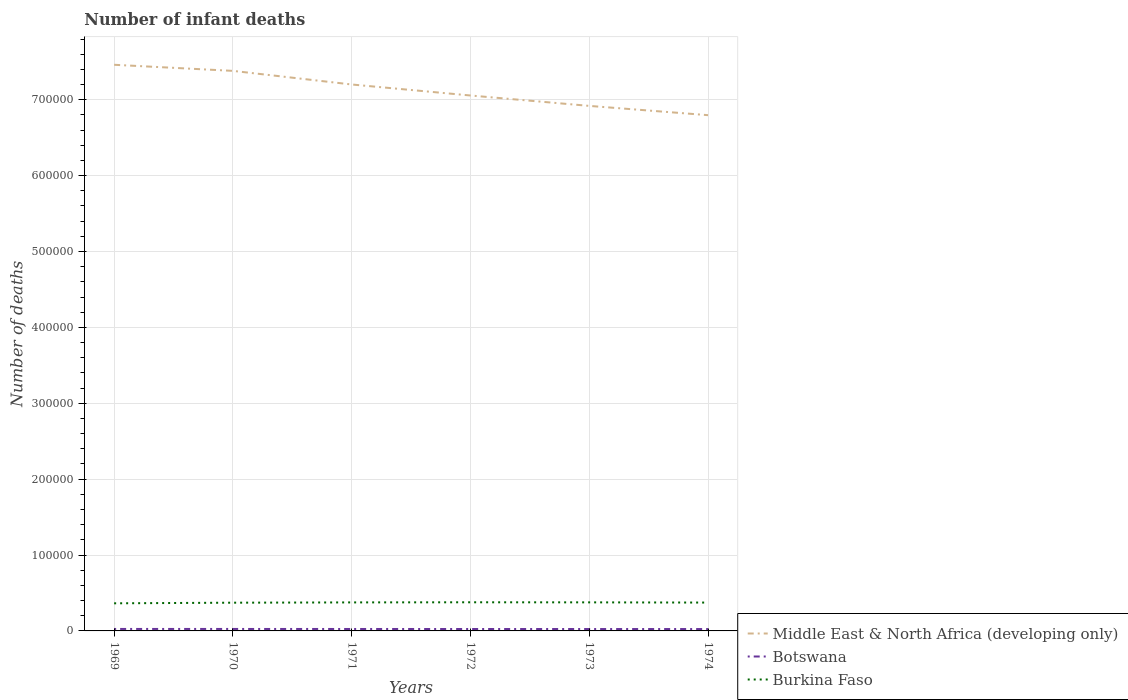Is the number of lines equal to the number of legend labels?
Provide a short and direct response. Yes. Across all years, what is the maximum number of infant deaths in Botswana?
Provide a succinct answer. 2476. In which year was the number of infant deaths in Burkina Faso maximum?
Offer a very short reply. 1969. What is the total number of infant deaths in Botswana in the graph?
Your response must be concise. 127. What is the difference between the highest and the second highest number of infant deaths in Middle East & North Africa (developing only)?
Make the answer very short. 6.64e+04. What is the difference between the highest and the lowest number of infant deaths in Botswana?
Make the answer very short. 3. How many lines are there?
Make the answer very short. 3. How many years are there in the graph?
Offer a very short reply. 6. How are the legend labels stacked?
Your response must be concise. Vertical. What is the title of the graph?
Your answer should be compact. Number of infant deaths. What is the label or title of the Y-axis?
Provide a short and direct response. Number of deaths. What is the Number of deaths of Middle East & North Africa (developing only) in 1969?
Keep it short and to the point. 7.46e+05. What is the Number of deaths of Botswana in 1969?
Give a very brief answer. 2603. What is the Number of deaths in Burkina Faso in 1969?
Provide a short and direct response. 3.64e+04. What is the Number of deaths in Middle East & North Africa (developing only) in 1970?
Ensure brevity in your answer.  7.38e+05. What is the Number of deaths of Botswana in 1970?
Your response must be concise. 2587. What is the Number of deaths of Burkina Faso in 1970?
Your answer should be compact. 3.72e+04. What is the Number of deaths in Middle East & North Africa (developing only) in 1971?
Your response must be concise. 7.20e+05. What is the Number of deaths in Botswana in 1971?
Provide a succinct answer. 2557. What is the Number of deaths in Burkina Faso in 1971?
Offer a very short reply. 3.76e+04. What is the Number of deaths of Middle East & North Africa (developing only) in 1972?
Make the answer very short. 7.06e+05. What is the Number of deaths of Botswana in 1972?
Ensure brevity in your answer.  2529. What is the Number of deaths of Burkina Faso in 1972?
Your response must be concise. 3.77e+04. What is the Number of deaths of Middle East & North Africa (developing only) in 1973?
Offer a terse response. 6.92e+05. What is the Number of deaths in Botswana in 1973?
Provide a succinct answer. 2500. What is the Number of deaths in Burkina Faso in 1973?
Offer a very short reply. 3.76e+04. What is the Number of deaths in Middle East & North Africa (developing only) in 1974?
Keep it short and to the point. 6.80e+05. What is the Number of deaths in Botswana in 1974?
Give a very brief answer. 2476. What is the Number of deaths in Burkina Faso in 1974?
Ensure brevity in your answer.  3.74e+04. Across all years, what is the maximum Number of deaths in Middle East & North Africa (developing only)?
Your response must be concise. 7.46e+05. Across all years, what is the maximum Number of deaths of Botswana?
Offer a very short reply. 2603. Across all years, what is the maximum Number of deaths of Burkina Faso?
Give a very brief answer. 3.77e+04. Across all years, what is the minimum Number of deaths of Middle East & North Africa (developing only)?
Your answer should be very brief. 6.80e+05. Across all years, what is the minimum Number of deaths of Botswana?
Provide a succinct answer. 2476. Across all years, what is the minimum Number of deaths of Burkina Faso?
Make the answer very short. 3.64e+04. What is the total Number of deaths of Middle East & North Africa (developing only) in the graph?
Offer a terse response. 4.28e+06. What is the total Number of deaths of Botswana in the graph?
Your response must be concise. 1.53e+04. What is the total Number of deaths in Burkina Faso in the graph?
Make the answer very short. 2.24e+05. What is the difference between the Number of deaths in Middle East & North Africa (developing only) in 1969 and that in 1970?
Offer a very short reply. 8013. What is the difference between the Number of deaths in Burkina Faso in 1969 and that in 1970?
Your answer should be compact. -810. What is the difference between the Number of deaths in Middle East & North Africa (developing only) in 1969 and that in 1971?
Provide a short and direct response. 2.60e+04. What is the difference between the Number of deaths of Burkina Faso in 1969 and that in 1971?
Keep it short and to the point. -1194. What is the difference between the Number of deaths in Middle East & North Africa (developing only) in 1969 and that in 1972?
Provide a short and direct response. 4.05e+04. What is the difference between the Number of deaths of Burkina Faso in 1969 and that in 1972?
Offer a terse response. -1365. What is the difference between the Number of deaths in Middle East & North Africa (developing only) in 1969 and that in 1973?
Your answer should be compact. 5.42e+04. What is the difference between the Number of deaths of Botswana in 1969 and that in 1973?
Provide a succinct answer. 103. What is the difference between the Number of deaths of Burkina Faso in 1969 and that in 1973?
Offer a terse response. -1258. What is the difference between the Number of deaths of Middle East & North Africa (developing only) in 1969 and that in 1974?
Ensure brevity in your answer.  6.64e+04. What is the difference between the Number of deaths of Botswana in 1969 and that in 1974?
Your answer should be compact. 127. What is the difference between the Number of deaths of Burkina Faso in 1969 and that in 1974?
Your response must be concise. -977. What is the difference between the Number of deaths of Middle East & North Africa (developing only) in 1970 and that in 1971?
Your answer should be compact. 1.79e+04. What is the difference between the Number of deaths in Botswana in 1970 and that in 1971?
Provide a succinct answer. 30. What is the difference between the Number of deaths of Burkina Faso in 1970 and that in 1971?
Give a very brief answer. -384. What is the difference between the Number of deaths in Middle East & North Africa (developing only) in 1970 and that in 1972?
Make the answer very short. 3.24e+04. What is the difference between the Number of deaths of Botswana in 1970 and that in 1972?
Your answer should be compact. 58. What is the difference between the Number of deaths in Burkina Faso in 1970 and that in 1972?
Keep it short and to the point. -555. What is the difference between the Number of deaths of Middle East & North Africa (developing only) in 1970 and that in 1973?
Keep it short and to the point. 4.62e+04. What is the difference between the Number of deaths of Botswana in 1970 and that in 1973?
Your response must be concise. 87. What is the difference between the Number of deaths of Burkina Faso in 1970 and that in 1973?
Offer a very short reply. -448. What is the difference between the Number of deaths in Middle East & North Africa (developing only) in 1970 and that in 1974?
Give a very brief answer. 5.84e+04. What is the difference between the Number of deaths in Botswana in 1970 and that in 1974?
Provide a succinct answer. 111. What is the difference between the Number of deaths of Burkina Faso in 1970 and that in 1974?
Ensure brevity in your answer.  -167. What is the difference between the Number of deaths of Middle East & North Africa (developing only) in 1971 and that in 1972?
Keep it short and to the point. 1.45e+04. What is the difference between the Number of deaths in Burkina Faso in 1971 and that in 1972?
Your response must be concise. -171. What is the difference between the Number of deaths in Middle East & North Africa (developing only) in 1971 and that in 1973?
Provide a short and direct response. 2.82e+04. What is the difference between the Number of deaths of Botswana in 1971 and that in 1973?
Ensure brevity in your answer.  57. What is the difference between the Number of deaths in Burkina Faso in 1971 and that in 1973?
Provide a succinct answer. -64. What is the difference between the Number of deaths in Middle East & North Africa (developing only) in 1971 and that in 1974?
Provide a short and direct response. 4.04e+04. What is the difference between the Number of deaths in Burkina Faso in 1971 and that in 1974?
Give a very brief answer. 217. What is the difference between the Number of deaths in Middle East & North Africa (developing only) in 1972 and that in 1973?
Provide a succinct answer. 1.37e+04. What is the difference between the Number of deaths of Botswana in 1972 and that in 1973?
Keep it short and to the point. 29. What is the difference between the Number of deaths of Burkina Faso in 1972 and that in 1973?
Make the answer very short. 107. What is the difference between the Number of deaths in Middle East & North Africa (developing only) in 1972 and that in 1974?
Provide a succinct answer. 2.59e+04. What is the difference between the Number of deaths in Burkina Faso in 1972 and that in 1974?
Your response must be concise. 388. What is the difference between the Number of deaths of Middle East & North Africa (developing only) in 1973 and that in 1974?
Give a very brief answer. 1.22e+04. What is the difference between the Number of deaths in Burkina Faso in 1973 and that in 1974?
Your answer should be compact. 281. What is the difference between the Number of deaths of Middle East & North Africa (developing only) in 1969 and the Number of deaths of Botswana in 1970?
Provide a short and direct response. 7.43e+05. What is the difference between the Number of deaths of Middle East & North Africa (developing only) in 1969 and the Number of deaths of Burkina Faso in 1970?
Provide a succinct answer. 7.09e+05. What is the difference between the Number of deaths of Botswana in 1969 and the Number of deaths of Burkina Faso in 1970?
Offer a terse response. -3.46e+04. What is the difference between the Number of deaths of Middle East & North Africa (developing only) in 1969 and the Number of deaths of Botswana in 1971?
Give a very brief answer. 7.43e+05. What is the difference between the Number of deaths of Middle East & North Africa (developing only) in 1969 and the Number of deaths of Burkina Faso in 1971?
Provide a short and direct response. 7.08e+05. What is the difference between the Number of deaths of Botswana in 1969 and the Number of deaths of Burkina Faso in 1971?
Ensure brevity in your answer.  -3.50e+04. What is the difference between the Number of deaths of Middle East & North Africa (developing only) in 1969 and the Number of deaths of Botswana in 1972?
Offer a very short reply. 7.44e+05. What is the difference between the Number of deaths in Middle East & North Africa (developing only) in 1969 and the Number of deaths in Burkina Faso in 1972?
Your answer should be very brief. 7.08e+05. What is the difference between the Number of deaths of Botswana in 1969 and the Number of deaths of Burkina Faso in 1972?
Make the answer very short. -3.51e+04. What is the difference between the Number of deaths of Middle East & North Africa (developing only) in 1969 and the Number of deaths of Botswana in 1973?
Your answer should be compact. 7.44e+05. What is the difference between the Number of deaths of Middle East & North Africa (developing only) in 1969 and the Number of deaths of Burkina Faso in 1973?
Your response must be concise. 7.08e+05. What is the difference between the Number of deaths in Botswana in 1969 and the Number of deaths in Burkina Faso in 1973?
Your response must be concise. -3.50e+04. What is the difference between the Number of deaths in Middle East & North Africa (developing only) in 1969 and the Number of deaths in Botswana in 1974?
Make the answer very short. 7.44e+05. What is the difference between the Number of deaths in Middle East & North Africa (developing only) in 1969 and the Number of deaths in Burkina Faso in 1974?
Provide a short and direct response. 7.09e+05. What is the difference between the Number of deaths of Botswana in 1969 and the Number of deaths of Burkina Faso in 1974?
Your answer should be compact. -3.48e+04. What is the difference between the Number of deaths in Middle East & North Africa (developing only) in 1970 and the Number of deaths in Botswana in 1971?
Provide a succinct answer. 7.35e+05. What is the difference between the Number of deaths in Middle East & North Africa (developing only) in 1970 and the Number of deaths in Burkina Faso in 1971?
Keep it short and to the point. 7.00e+05. What is the difference between the Number of deaths of Botswana in 1970 and the Number of deaths of Burkina Faso in 1971?
Offer a terse response. -3.50e+04. What is the difference between the Number of deaths of Middle East & North Africa (developing only) in 1970 and the Number of deaths of Botswana in 1972?
Give a very brief answer. 7.35e+05. What is the difference between the Number of deaths in Middle East & North Africa (developing only) in 1970 and the Number of deaths in Burkina Faso in 1972?
Provide a short and direct response. 7.00e+05. What is the difference between the Number of deaths in Botswana in 1970 and the Number of deaths in Burkina Faso in 1972?
Give a very brief answer. -3.52e+04. What is the difference between the Number of deaths of Middle East & North Africa (developing only) in 1970 and the Number of deaths of Botswana in 1973?
Your answer should be compact. 7.36e+05. What is the difference between the Number of deaths of Middle East & North Africa (developing only) in 1970 and the Number of deaths of Burkina Faso in 1973?
Your answer should be very brief. 7.00e+05. What is the difference between the Number of deaths of Botswana in 1970 and the Number of deaths of Burkina Faso in 1973?
Your answer should be compact. -3.51e+04. What is the difference between the Number of deaths in Middle East & North Africa (developing only) in 1970 and the Number of deaths in Botswana in 1974?
Ensure brevity in your answer.  7.36e+05. What is the difference between the Number of deaths in Middle East & North Africa (developing only) in 1970 and the Number of deaths in Burkina Faso in 1974?
Your answer should be compact. 7.01e+05. What is the difference between the Number of deaths in Botswana in 1970 and the Number of deaths in Burkina Faso in 1974?
Provide a succinct answer. -3.48e+04. What is the difference between the Number of deaths of Middle East & North Africa (developing only) in 1971 and the Number of deaths of Botswana in 1972?
Your response must be concise. 7.18e+05. What is the difference between the Number of deaths in Middle East & North Africa (developing only) in 1971 and the Number of deaths in Burkina Faso in 1972?
Give a very brief answer. 6.82e+05. What is the difference between the Number of deaths in Botswana in 1971 and the Number of deaths in Burkina Faso in 1972?
Your response must be concise. -3.52e+04. What is the difference between the Number of deaths in Middle East & North Africa (developing only) in 1971 and the Number of deaths in Botswana in 1973?
Keep it short and to the point. 7.18e+05. What is the difference between the Number of deaths of Middle East & North Africa (developing only) in 1971 and the Number of deaths of Burkina Faso in 1973?
Ensure brevity in your answer.  6.82e+05. What is the difference between the Number of deaths of Botswana in 1971 and the Number of deaths of Burkina Faso in 1973?
Your response must be concise. -3.51e+04. What is the difference between the Number of deaths in Middle East & North Africa (developing only) in 1971 and the Number of deaths in Botswana in 1974?
Keep it short and to the point. 7.18e+05. What is the difference between the Number of deaths in Middle East & North Africa (developing only) in 1971 and the Number of deaths in Burkina Faso in 1974?
Keep it short and to the point. 6.83e+05. What is the difference between the Number of deaths in Botswana in 1971 and the Number of deaths in Burkina Faso in 1974?
Provide a short and direct response. -3.48e+04. What is the difference between the Number of deaths in Middle East & North Africa (developing only) in 1972 and the Number of deaths in Botswana in 1973?
Offer a very short reply. 7.03e+05. What is the difference between the Number of deaths in Middle East & North Africa (developing only) in 1972 and the Number of deaths in Burkina Faso in 1973?
Your answer should be compact. 6.68e+05. What is the difference between the Number of deaths in Botswana in 1972 and the Number of deaths in Burkina Faso in 1973?
Provide a succinct answer. -3.51e+04. What is the difference between the Number of deaths of Middle East & North Africa (developing only) in 1972 and the Number of deaths of Botswana in 1974?
Your answer should be compact. 7.03e+05. What is the difference between the Number of deaths in Middle East & North Africa (developing only) in 1972 and the Number of deaths in Burkina Faso in 1974?
Your answer should be compact. 6.68e+05. What is the difference between the Number of deaths of Botswana in 1972 and the Number of deaths of Burkina Faso in 1974?
Give a very brief answer. -3.48e+04. What is the difference between the Number of deaths in Middle East & North Africa (developing only) in 1973 and the Number of deaths in Botswana in 1974?
Your answer should be compact. 6.89e+05. What is the difference between the Number of deaths of Middle East & North Africa (developing only) in 1973 and the Number of deaths of Burkina Faso in 1974?
Your answer should be very brief. 6.54e+05. What is the difference between the Number of deaths in Botswana in 1973 and the Number of deaths in Burkina Faso in 1974?
Your answer should be compact. -3.49e+04. What is the average Number of deaths of Middle East & North Africa (developing only) per year?
Your response must be concise. 7.14e+05. What is the average Number of deaths of Botswana per year?
Make the answer very short. 2542. What is the average Number of deaths of Burkina Faso per year?
Keep it short and to the point. 3.73e+04. In the year 1969, what is the difference between the Number of deaths in Middle East & North Africa (developing only) and Number of deaths in Botswana?
Keep it short and to the point. 7.43e+05. In the year 1969, what is the difference between the Number of deaths in Middle East & North Africa (developing only) and Number of deaths in Burkina Faso?
Your response must be concise. 7.10e+05. In the year 1969, what is the difference between the Number of deaths in Botswana and Number of deaths in Burkina Faso?
Provide a short and direct response. -3.38e+04. In the year 1970, what is the difference between the Number of deaths in Middle East & North Africa (developing only) and Number of deaths in Botswana?
Offer a terse response. 7.35e+05. In the year 1970, what is the difference between the Number of deaths in Middle East & North Africa (developing only) and Number of deaths in Burkina Faso?
Your response must be concise. 7.01e+05. In the year 1970, what is the difference between the Number of deaths of Botswana and Number of deaths of Burkina Faso?
Provide a succinct answer. -3.46e+04. In the year 1971, what is the difference between the Number of deaths in Middle East & North Africa (developing only) and Number of deaths in Botswana?
Provide a succinct answer. 7.18e+05. In the year 1971, what is the difference between the Number of deaths of Middle East & North Africa (developing only) and Number of deaths of Burkina Faso?
Offer a terse response. 6.82e+05. In the year 1971, what is the difference between the Number of deaths in Botswana and Number of deaths in Burkina Faso?
Your answer should be very brief. -3.50e+04. In the year 1972, what is the difference between the Number of deaths in Middle East & North Africa (developing only) and Number of deaths in Botswana?
Give a very brief answer. 7.03e+05. In the year 1972, what is the difference between the Number of deaths of Middle East & North Africa (developing only) and Number of deaths of Burkina Faso?
Provide a succinct answer. 6.68e+05. In the year 1972, what is the difference between the Number of deaths of Botswana and Number of deaths of Burkina Faso?
Give a very brief answer. -3.52e+04. In the year 1973, what is the difference between the Number of deaths of Middle East & North Africa (developing only) and Number of deaths of Botswana?
Offer a terse response. 6.89e+05. In the year 1973, what is the difference between the Number of deaths in Middle East & North Africa (developing only) and Number of deaths in Burkina Faso?
Ensure brevity in your answer.  6.54e+05. In the year 1973, what is the difference between the Number of deaths in Botswana and Number of deaths in Burkina Faso?
Your answer should be compact. -3.51e+04. In the year 1974, what is the difference between the Number of deaths in Middle East & North Africa (developing only) and Number of deaths in Botswana?
Provide a succinct answer. 6.77e+05. In the year 1974, what is the difference between the Number of deaths in Middle East & North Africa (developing only) and Number of deaths in Burkina Faso?
Offer a terse response. 6.42e+05. In the year 1974, what is the difference between the Number of deaths in Botswana and Number of deaths in Burkina Faso?
Provide a succinct answer. -3.49e+04. What is the ratio of the Number of deaths in Middle East & North Africa (developing only) in 1969 to that in 1970?
Ensure brevity in your answer.  1.01. What is the ratio of the Number of deaths of Botswana in 1969 to that in 1970?
Your response must be concise. 1.01. What is the ratio of the Number of deaths of Burkina Faso in 1969 to that in 1970?
Provide a succinct answer. 0.98. What is the ratio of the Number of deaths in Middle East & North Africa (developing only) in 1969 to that in 1971?
Make the answer very short. 1.04. What is the ratio of the Number of deaths of Botswana in 1969 to that in 1971?
Your answer should be compact. 1.02. What is the ratio of the Number of deaths in Burkina Faso in 1969 to that in 1971?
Your answer should be compact. 0.97. What is the ratio of the Number of deaths of Middle East & North Africa (developing only) in 1969 to that in 1972?
Offer a terse response. 1.06. What is the ratio of the Number of deaths of Botswana in 1969 to that in 1972?
Provide a succinct answer. 1.03. What is the ratio of the Number of deaths in Burkina Faso in 1969 to that in 1972?
Provide a succinct answer. 0.96. What is the ratio of the Number of deaths in Middle East & North Africa (developing only) in 1969 to that in 1973?
Give a very brief answer. 1.08. What is the ratio of the Number of deaths in Botswana in 1969 to that in 1973?
Ensure brevity in your answer.  1.04. What is the ratio of the Number of deaths of Burkina Faso in 1969 to that in 1973?
Keep it short and to the point. 0.97. What is the ratio of the Number of deaths in Middle East & North Africa (developing only) in 1969 to that in 1974?
Make the answer very short. 1.1. What is the ratio of the Number of deaths in Botswana in 1969 to that in 1974?
Your response must be concise. 1.05. What is the ratio of the Number of deaths of Burkina Faso in 1969 to that in 1974?
Give a very brief answer. 0.97. What is the ratio of the Number of deaths of Middle East & North Africa (developing only) in 1970 to that in 1971?
Your response must be concise. 1.02. What is the ratio of the Number of deaths in Botswana in 1970 to that in 1971?
Keep it short and to the point. 1.01. What is the ratio of the Number of deaths of Burkina Faso in 1970 to that in 1971?
Your answer should be very brief. 0.99. What is the ratio of the Number of deaths of Middle East & North Africa (developing only) in 1970 to that in 1972?
Keep it short and to the point. 1.05. What is the ratio of the Number of deaths of Botswana in 1970 to that in 1972?
Give a very brief answer. 1.02. What is the ratio of the Number of deaths in Middle East & North Africa (developing only) in 1970 to that in 1973?
Offer a very short reply. 1.07. What is the ratio of the Number of deaths of Botswana in 1970 to that in 1973?
Ensure brevity in your answer.  1.03. What is the ratio of the Number of deaths of Middle East & North Africa (developing only) in 1970 to that in 1974?
Keep it short and to the point. 1.09. What is the ratio of the Number of deaths of Botswana in 1970 to that in 1974?
Provide a succinct answer. 1.04. What is the ratio of the Number of deaths in Middle East & North Africa (developing only) in 1971 to that in 1972?
Your answer should be compact. 1.02. What is the ratio of the Number of deaths in Botswana in 1971 to that in 1972?
Ensure brevity in your answer.  1.01. What is the ratio of the Number of deaths of Burkina Faso in 1971 to that in 1972?
Make the answer very short. 1. What is the ratio of the Number of deaths of Middle East & North Africa (developing only) in 1971 to that in 1973?
Give a very brief answer. 1.04. What is the ratio of the Number of deaths of Botswana in 1971 to that in 1973?
Your response must be concise. 1.02. What is the ratio of the Number of deaths of Middle East & North Africa (developing only) in 1971 to that in 1974?
Give a very brief answer. 1.06. What is the ratio of the Number of deaths of Botswana in 1971 to that in 1974?
Ensure brevity in your answer.  1.03. What is the ratio of the Number of deaths of Middle East & North Africa (developing only) in 1972 to that in 1973?
Your response must be concise. 1.02. What is the ratio of the Number of deaths of Botswana in 1972 to that in 1973?
Keep it short and to the point. 1.01. What is the ratio of the Number of deaths in Burkina Faso in 1972 to that in 1973?
Give a very brief answer. 1. What is the ratio of the Number of deaths of Middle East & North Africa (developing only) in 1972 to that in 1974?
Offer a very short reply. 1.04. What is the ratio of the Number of deaths in Botswana in 1972 to that in 1974?
Your answer should be compact. 1.02. What is the ratio of the Number of deaths in Burkina Faso in 1972 to that in 1974?
Your response must be concise. 1.01. What is the ratio of the Number of deaths in Botswana in 1973 to that in 1974?
Make the answer very short. 1.01. What is the ratio of the Number of deaths of Burkina Faso in 1973 to that in 1974?
Keep it short and to the point. 1.01. What is the difference between the highest and the second highest Number of deaths in Middle East & North Africa (developing only)?
Provide a succinct answer. 8013. What is the difference between the highest and the second highest Number of deaths in Botswana?
Give a very brief answer. 16. What is the difference between the highest and the second highest Number of deaths in Burkina Faso?
Offer a very short reply. 107. What is the difference between the highest and the lowest Number of deaths in Middle East & North Africa (developing only)?
Your answer should be compact. 6.64e+04. What is the difference between the highest and the lowest Number of deaths of Botswana?
Make the answer very short. 127. What is the difference between the highest and the lowest Number of deaths in Burkina Faso?
Your answer should be very brief. 1365. 